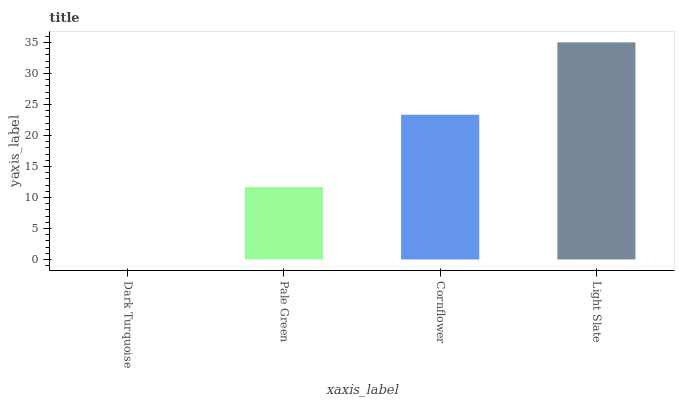Is Dark Turquoise the minimum?
Answer yes or no. Yes. Is Light Slate the maximum?
Answer yes or no. Yes. Is Pale Green the minimum?
Answer yes or no. No. Is Pale Green the maximum?
Answer yes or no. No. Is Pale Green greater than Dark Turquoise?
Answer yes or no. Yes. Is Dark Turquoise less than Pale Green?
Answer yes or no. Yes. Is Dark Turquoise greater than Pale Green?
Answer yes or no. No. Is Pale Green less than Dark Turquoise?
Answer yes or no. No. Is Cornflower the high median?
Answer yes or no. Yes. Is Pale Green the low median?
Answer yes or no. Yes. Is Dark Turquoise the high median?
Answer yes or no. No. Is Dark Turquoise the low median?
Answer yes or no. No. 